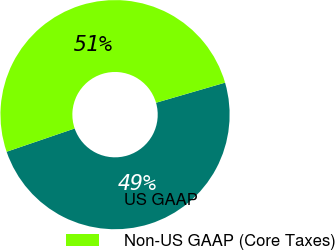Convert chart. <chart><loc_0><loc_0><loc_500><loc_500><pie_chart><fcel>US GAAP<fcel>Non-US GAAP (Core Taxes)<nl><fcel>49.26%<fcel>50.74%<nl></chart> 